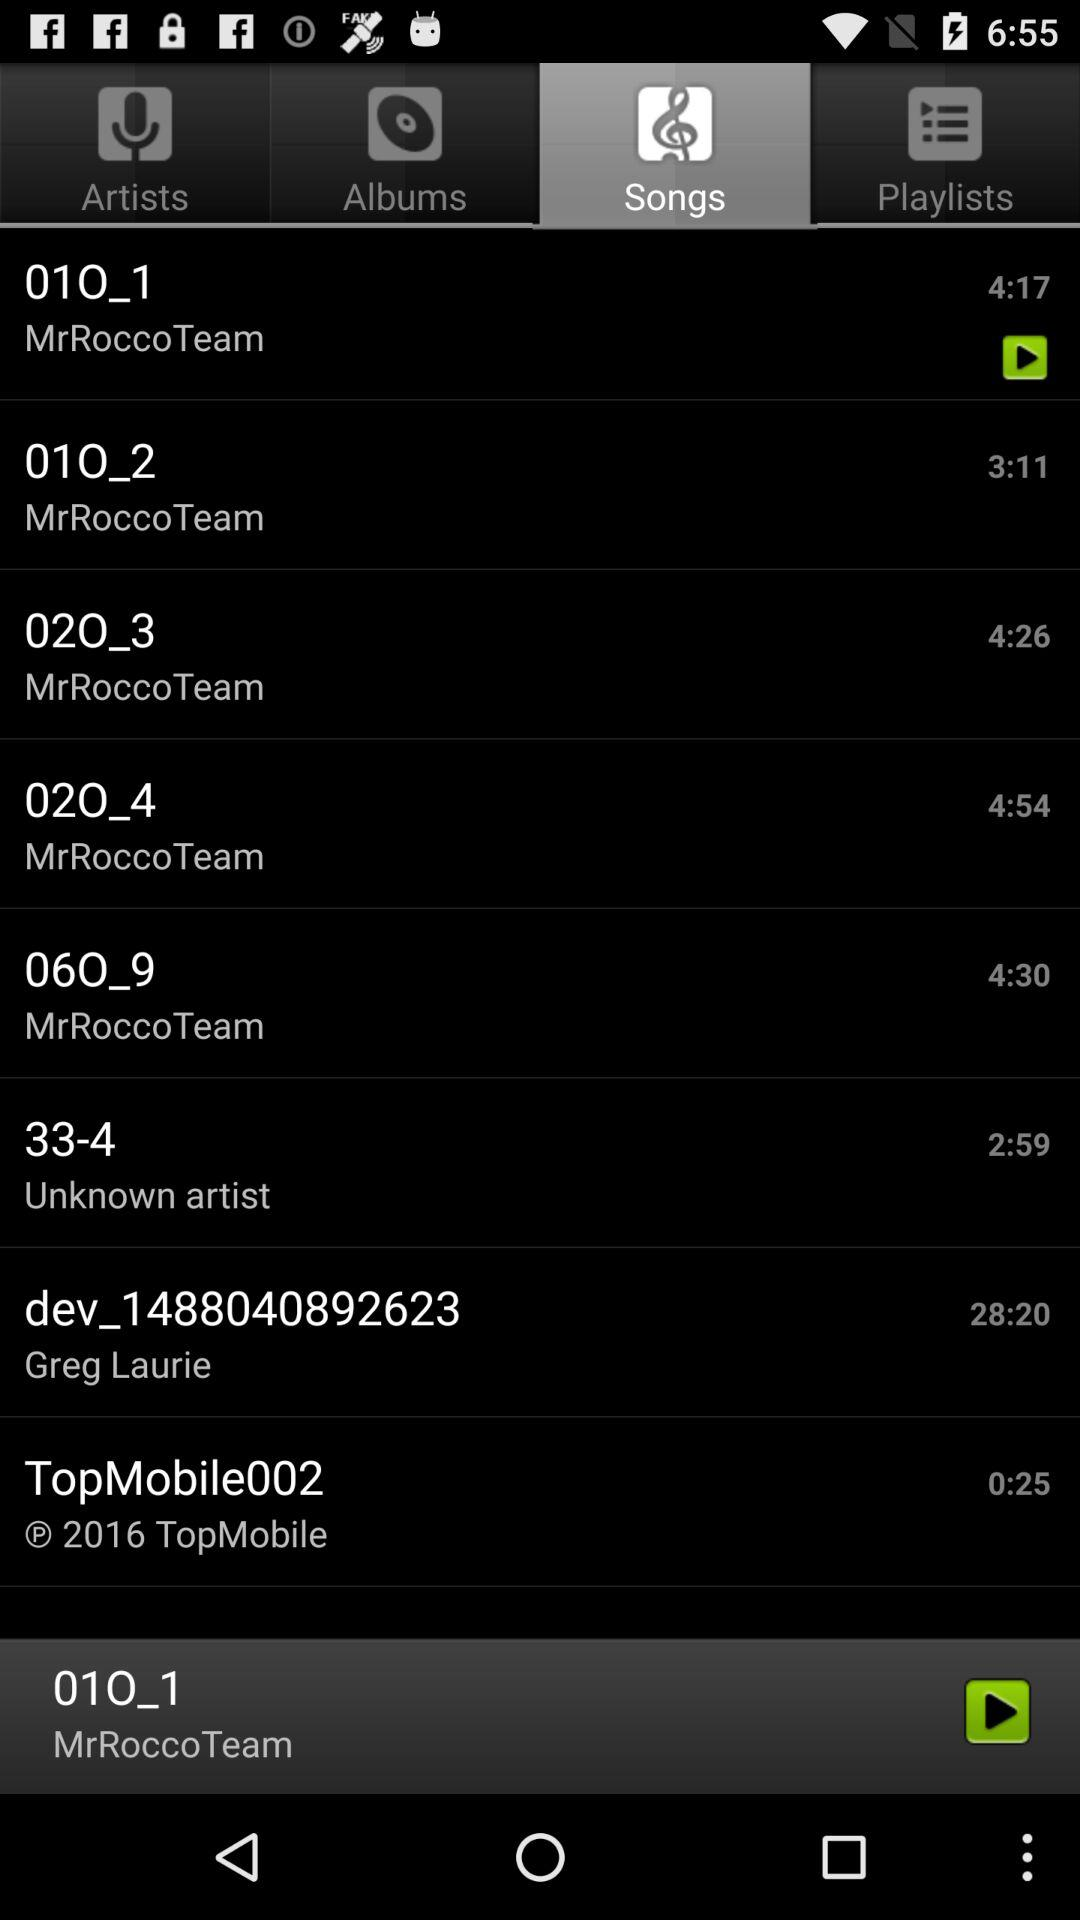Which song was last played? The last played song was "01O_1". 